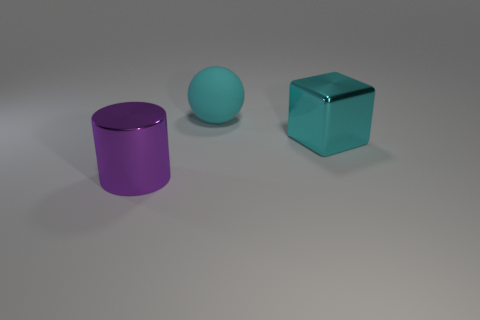Add 3 small cyan rubber cylinders. How many objects exist? 6 Subtract all blocks. How many objects are left? 2 Subtract 0 green cylinders. How many objects are left? 3 Subtract all large cyan metallic balls. Subtract all big cylinders. How many objects are left? 2 Add 3 big cyan spheres. How many big cyan spheres are left? 4 Add 1 big purple metal objects. How many big purple metal objects exist? 2 